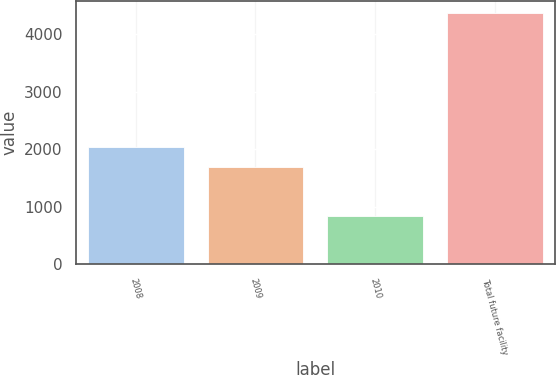Convert chart to OTSL. <chart><loc_0><loc_0><loc_500><loc_500><bar_chart><fcel>2008<fcel>2009<fcel>2010<fcel>Total future facility<nl><fcel>2035<fcel>1683<fcel>838<fcel>4358<nl></chart> 